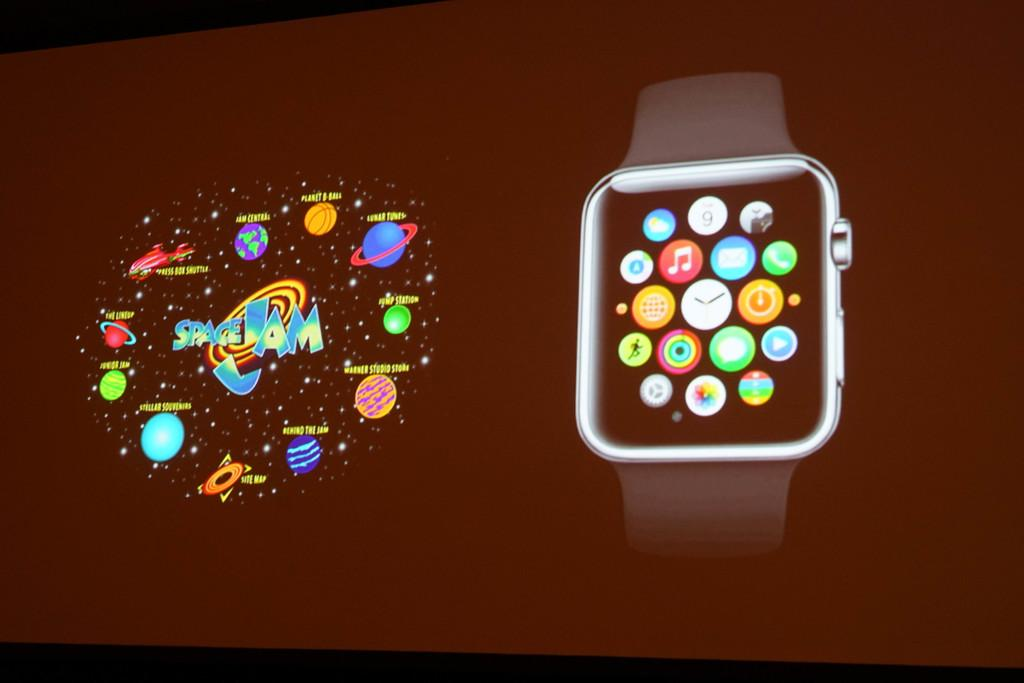<image>
Share a concise interpretation of the image provided. A screen of the apple watch and a Space Jam layout. 